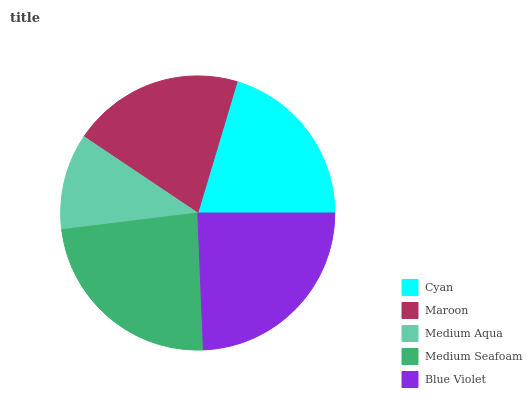Is Medium Aqua the minimum?
Answer yes or no. Yes. Is Blue Violet the maximum?
Answer yes or no. Yes. Is Maroon the minimum?
Answer yes or no. No. Is Maroon the maximum?
Answer yes or no. No. Is Cyan greater than Maroon?
Answer yes or no. Yes. Is Maroon less than Cyan?
Answer yes or no. Yes. Is Maroon greater than Cyan?
Answer yes or no. No. Is Cyan less than Maroon?
Answer yes or no. No. Is Cyan the high median?
Answer yes or no. Yes. Is Cyan the low median?
Answer yes or no. Yes. Is Blue Violet the high median?
Answer yes or no. No. Is Medium Seafoam the low median?
Answer yes or no. No. 